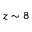<formula> <loc_0><loc_0><loc_500><loc_500>z \sim 8</formula> 